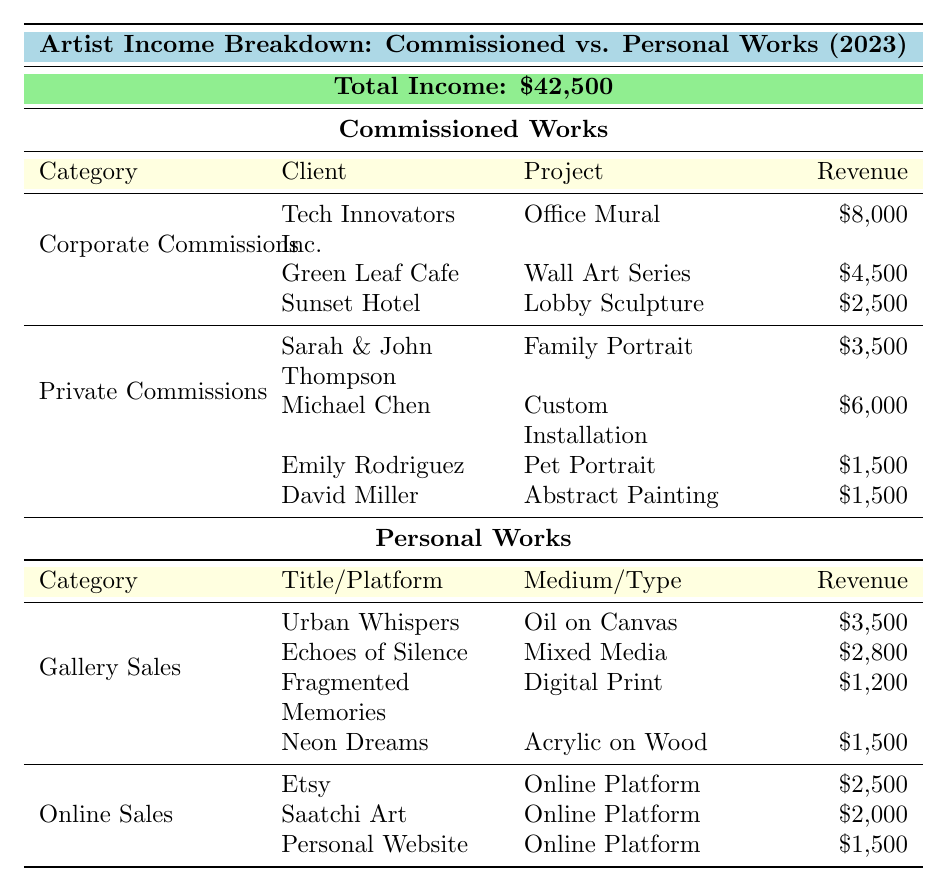What is the total income from commissioned works in 2023? The table specifies that the total income from commissioned works is broken down into Corporate Commissions ($15,000) and Private Commissions ($12,500). By adding these amounts together: $15,000 + $12,500 = $27,500.
Answer: $27,500 How much income did the artist generate from gallery sales? According to the table, the income from gallery sales is listed as $9,000. This figure encompasses the various artworks sold in galleries.
Answer: $9,000 Which project generated the highest revenue in corporate commissions? Within the corporate commissions, the project "Office Mural" by Tech Innovators Inc. generated the highest revenue of $8,000 compared to the other projects listed.
Answer: Office Mural What is the total revenue from personal works? The table indicates that personal works consist of gallery sales ($9,000) and online sales ($6,000). Summing these figures gives: $9,000 + $6,000 = $15,000.
Answer: $15,000 Is the revenue from online sales greater than the revenue from private commissions? The revenue from online sales is $6,000, while the revenue from private commissions is $12,500. Since $6,000 is less than $12,500, the statement is false.
Answer: No What is the average income the artist earned from each project under private commissions? The artist has four projects listed under private commissions with revenues of $3,500, $6,000, $1,500, and $1,500. First, add these: $3,500 + $6,000 + $1,500 + $1,500 = $12,500. Then divide by the number of projects (4), giving: $12,500 / 4 = $3,125.
Answer: $3,125 What percentage of the total income comes from commissioned works? The total income is $42,500, and the income from commissioned works is $27,500. To find the percentage: ($27,500 / $42,500) × 100 = 64.71%. Thus, approximately 64.71% of the total income is from commissioned works.
Answer: 64.71% What is the total revenue from personal works compared to the corporate commissions? The total revenue from personal works is $15,000, while corporate commissions generated $15,000. They are equal, meaning personal works and corporate commissions brought in the same revenue.
Answer: They are equal Which client commissioned the highest-paying project under private commissions? The highest-paying project under private commissions is from Michael Chen for the Custom Installation, which generated $6,000.
Answer: Michael Chen How many projects were completed under corporate commissions? The table lists three projects completed under corporate commissions: "Office Mural," "Wall Art Series," and "Lobby Sculpture." Therefore, the artist completed three projects in this category.
Answer: Three projects 